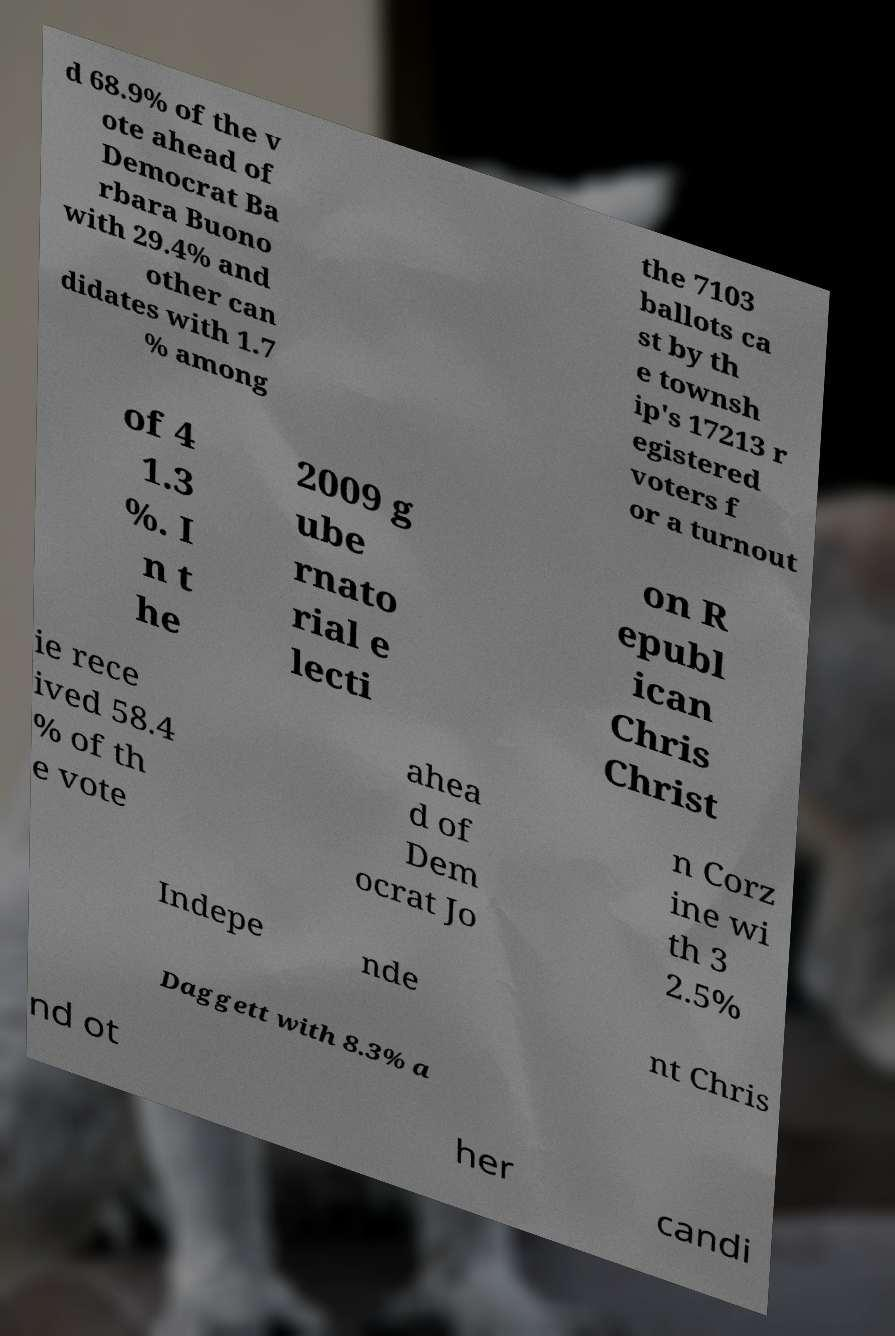For documentation purposes, I need the text within this image transcribed. Could you provide that? d 68.9% of the v ote ahead of Democrat Ba rbara Buono with 29.4% and other can didates with 1.7 % among the 7103 ballots ca st by th e townsh ip's 17213 r egistered voters f or a turnout of 4 1.3 %. I n t he 2009 g ube rnato rial e lecti on R epubl ican Chris Christ ie rece ived 58.4 % of th e vote ahea d of Dem ocrat Jo n Corz ine wi th 3 2.5% Indepe nde nt Chris Daggett with 8.3% a nd ot her candi 